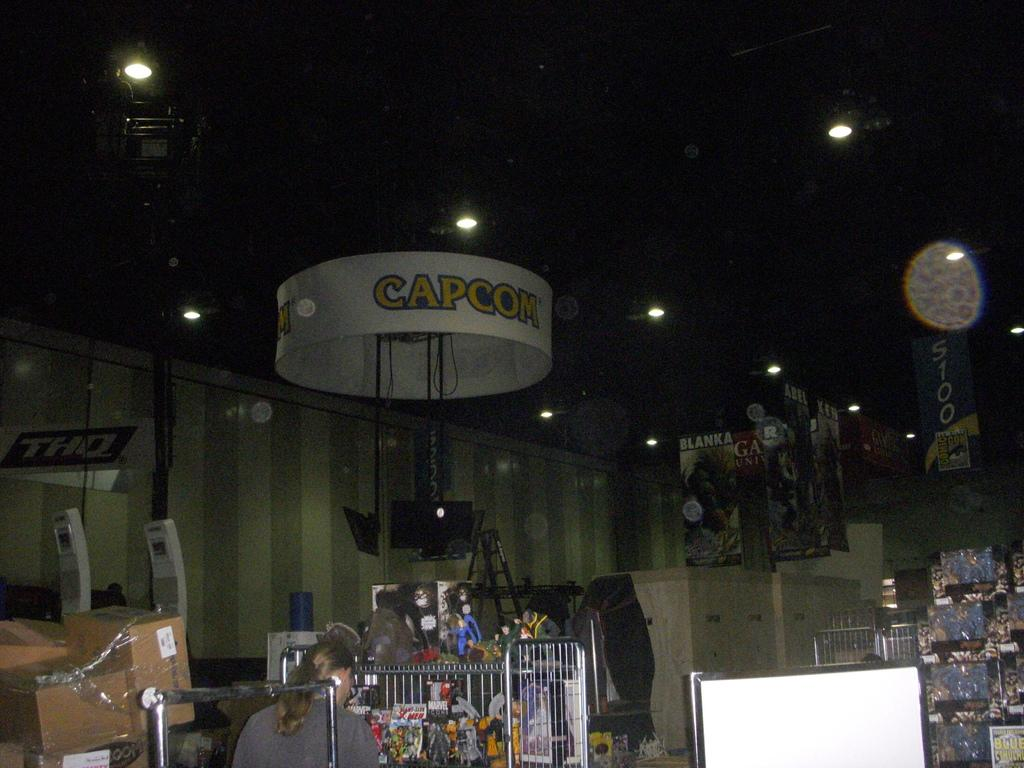What type of structures are present in the image? There are stands, boards, and boxes in the image. What type of signage is visible in the image? There are banners in the image. Are there any additional unspecified objects in the image? Yes, there are unspecified objects in the image. What can be seen at the top of the image? There are lights at the top of the image. What type of background is present in the image? There is a wall in the image. Is there a person present in the image? Yes, there is a person standing in the image. Can you tell me how many girls are shaking a carriage in the image? There are no girls or carriages present in the image. What type of animal is pulling the carriage in the image? There is no carriage or animal present in the image. 